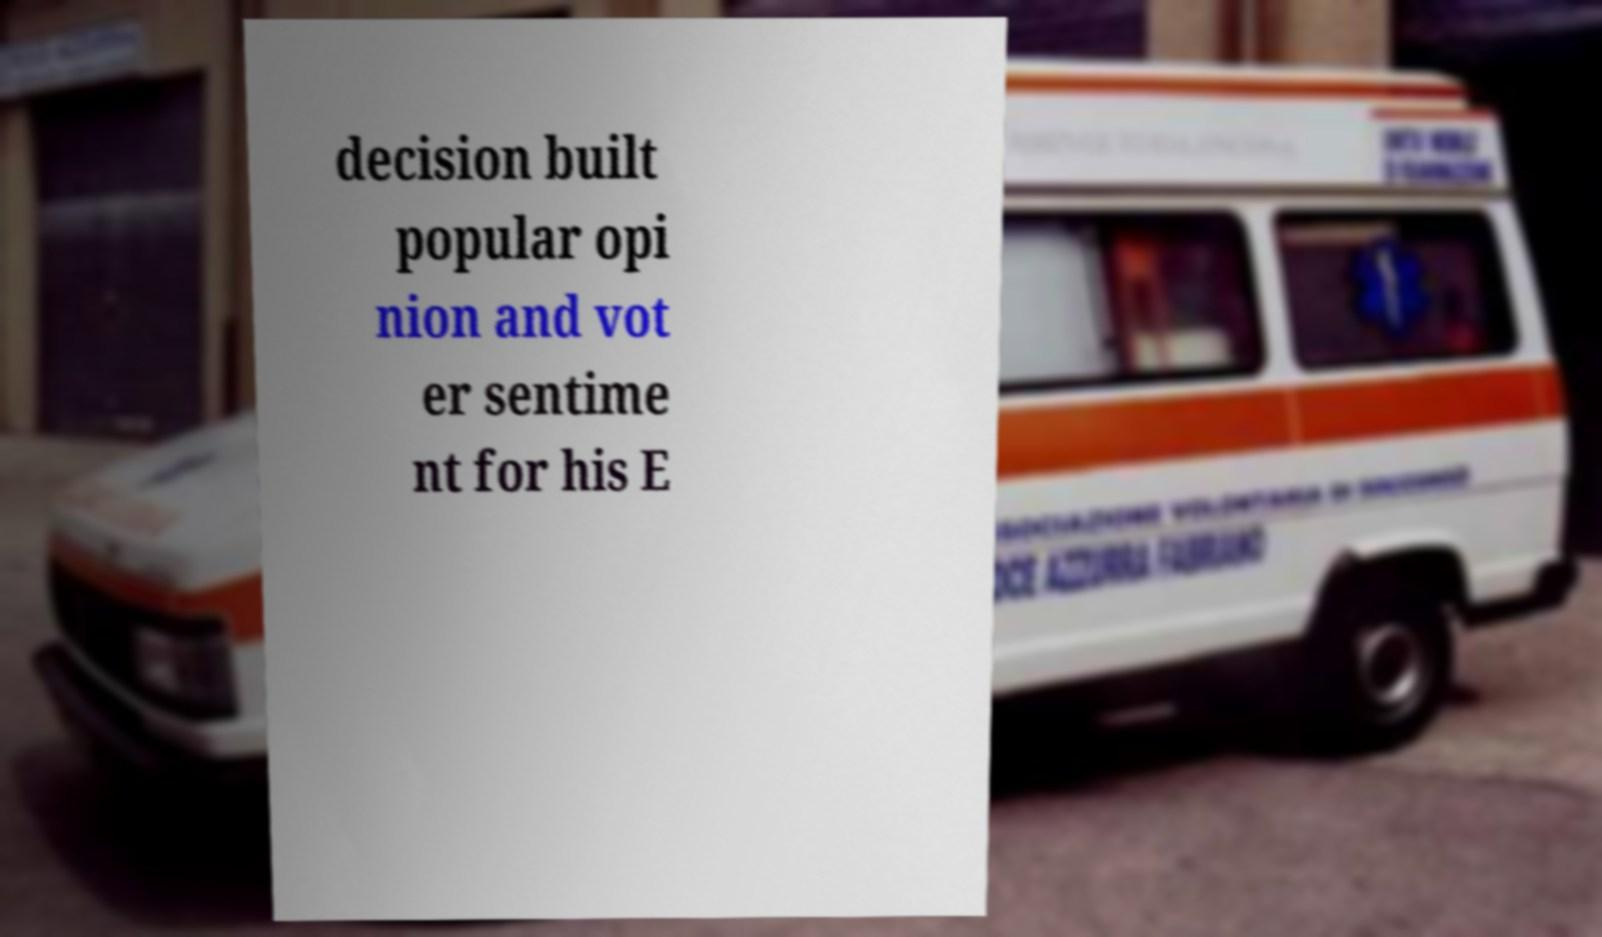I need the written content from this picture converted into text. Can you do that? decision built popular opi nion and vot er sentime nt for his E 